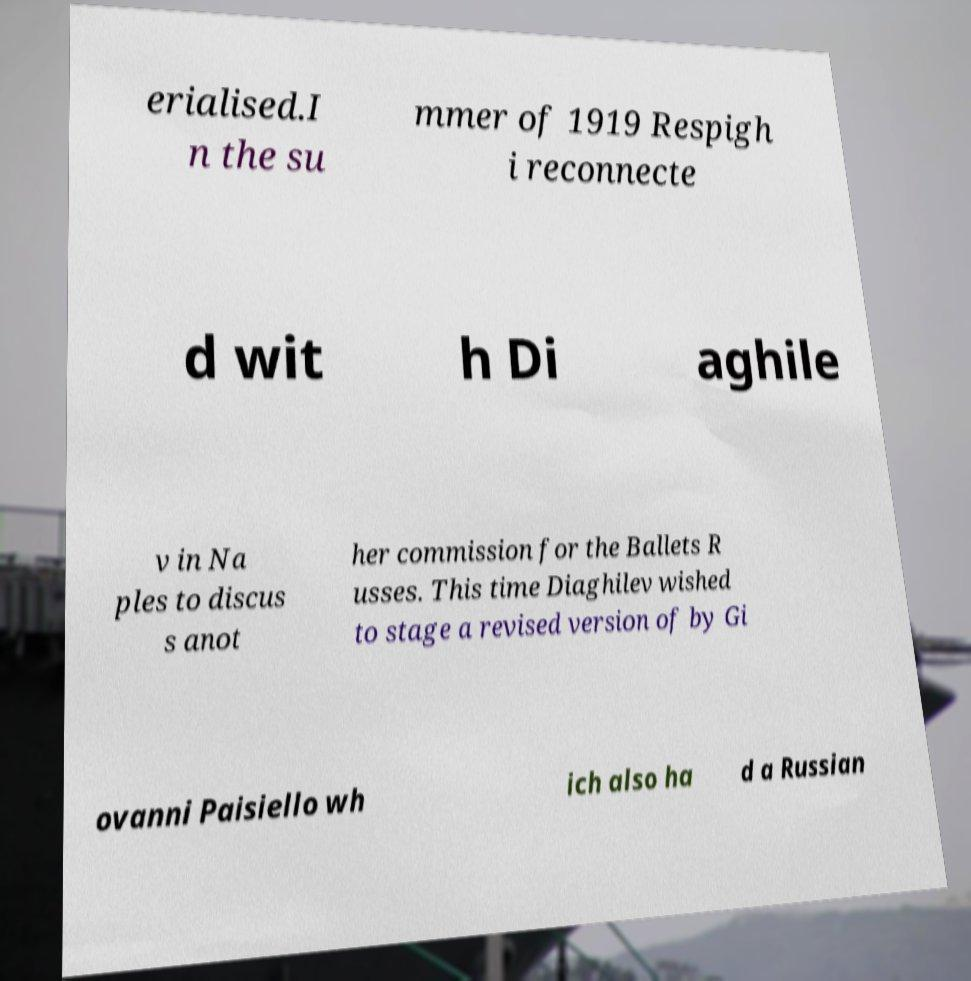Please read and relay the text visible in this image. What does it say? erialised.I n the su mmer of 1919 Respigh i reconnecte d wit h Di aghile v in Na ples to discus s anot her commission for the Ballets R usses. This time Diaghilev wished to stage a revised version of by Gi ovanni Paisiello wh ich also ha d a Russian 